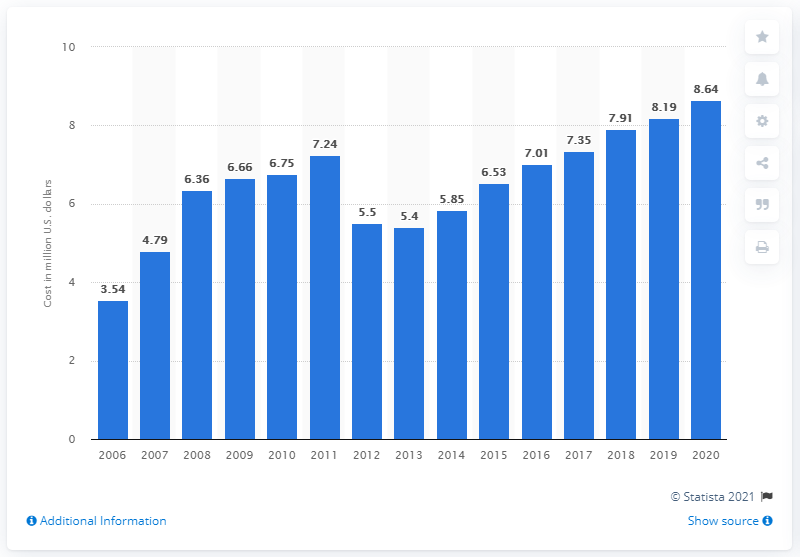Give some essential details in this illustration. In 2020, the average cost to businesses in the United States that were affected by a data breach was approximately $8.64 per compromised record. In the previous year, the average cost to businesses that were affected by a data breach was $8.19 per compromised record. 